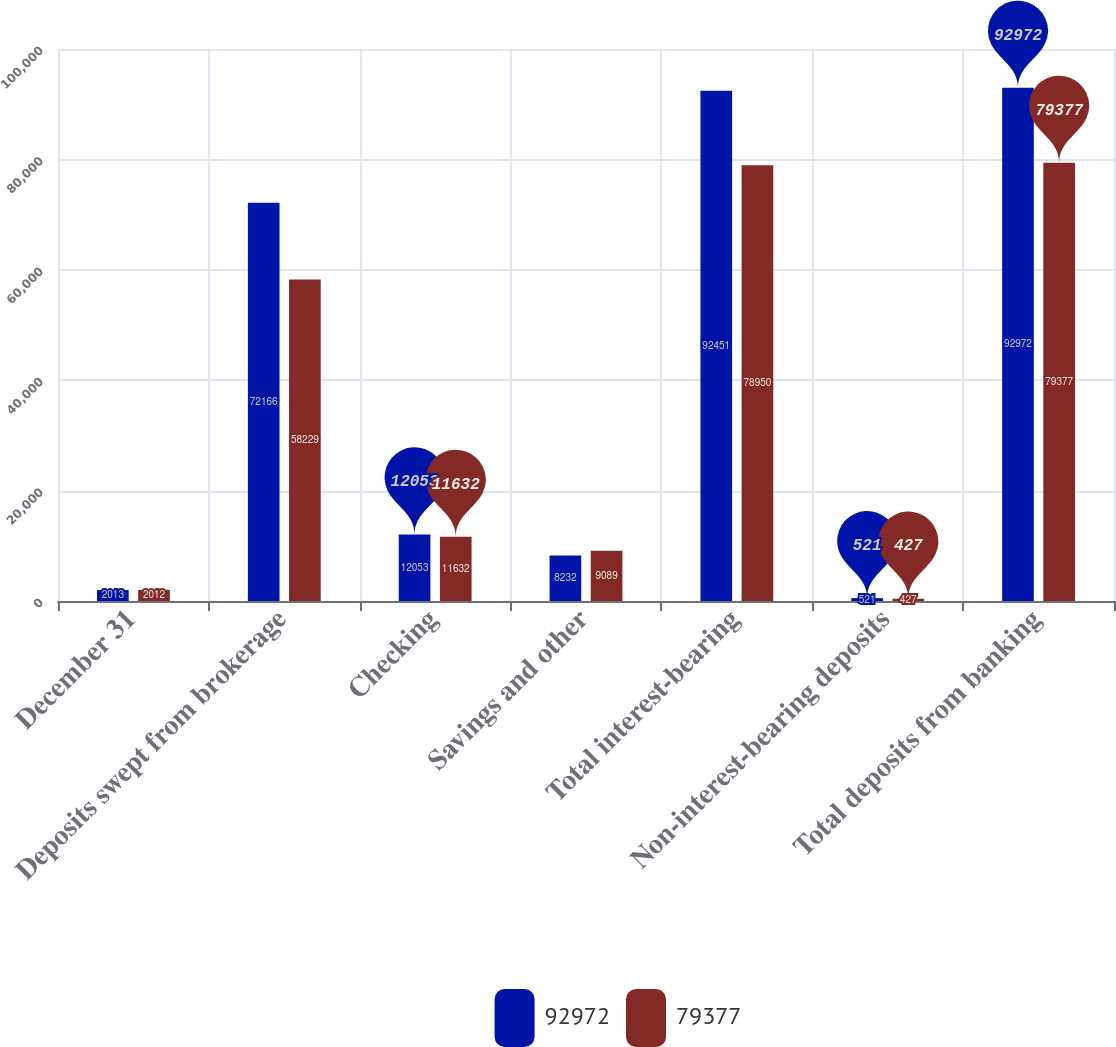Convert chart to OTSL. <chart><loc_0><loc_0><loc_500><loc_500><stacked_bar_chart><ecel><fcel>December 31<fcel>Deposits swept from brokerage<fcel>Checking<fcel>Savings and other<fcel>Total interest-bearing<fcel>Non-interest-bearing deposits<fcel>Total deposits from banking<nl><fcel>92972<fcel>2013<fcel>72166<fcel>12053<fcel>8232<fcel>92451<fcel>521<fcel>92972<nl><fcel>79377<fcel>2012<fcel>58229<fcel>11632<fcel>9089<fcel>78950<fcel>427<fcel>79377<nl></chart> 